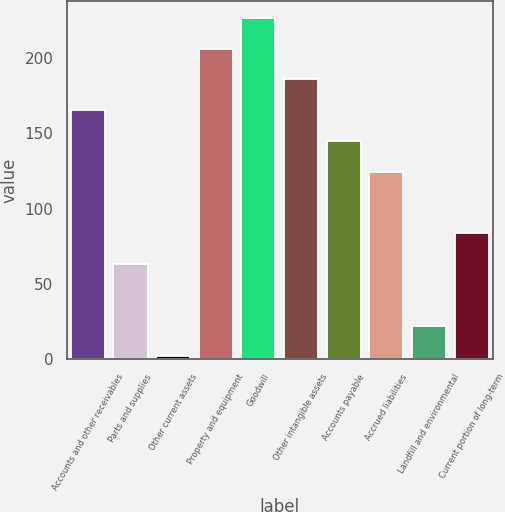<chart> <loc_0><loc_0><loc_500><loc_500><bar_chart><fcel>Accounts and other receivables<fcel>Parts and supplies<fcel>Other current assets<fcel>Property and equipment<fcel>Goodwill<fcel>Other intangible assets<fcel>Accounts payable<fcel>Accrued liabilities<fcel>Landfill and environmental<fcel>Current portion of long-term<nl><fcel>165.2<fcel>63.2<fcel>2<fcel>206<fcel>226.4<fcel>185.6<fcel>144.8<fcel>124.4<fcel>22.4<fcel>83.6<nl></chart> 